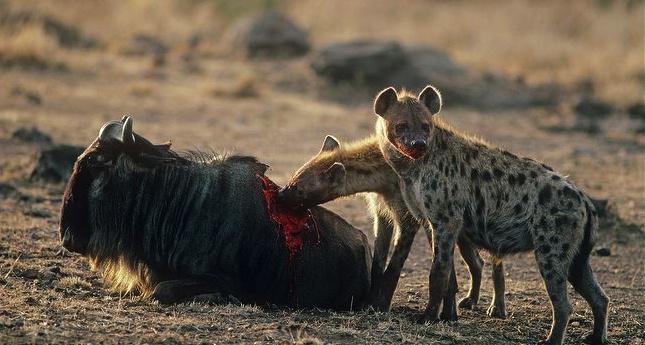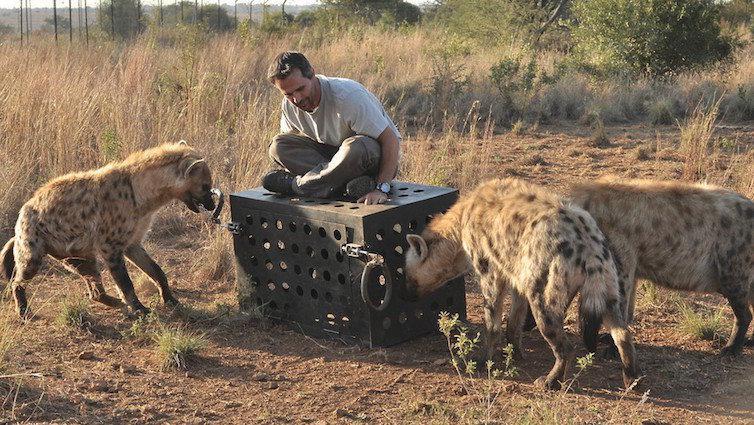The first image is the image on the left, the second image is the image on the right. Analyze the images presented: Is the assertion "An image shows a man posed with three hyenas." valid? Answer yes or no. Yes. The first image is the image on the left, the second image is the image on the right. Assess this claim about the two images: "In one of the images there is a man surrounded by multiple hyenas.". Correct or not? Answer yes or no. Yes. 